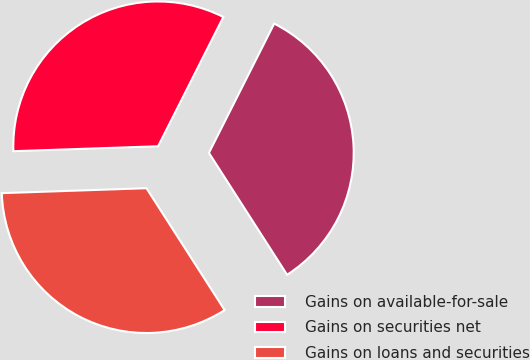Convert chart. <chart><loc_0><loc_0><loc_500><loc_500><pie_chart><fcel>Gains on available-for-sale<fcel>Gains on securities net<fcel>Gains on loans and securities<nl><fcel>33.48%<fcel>32.98%<fcel>33.53%<nl></chart> 